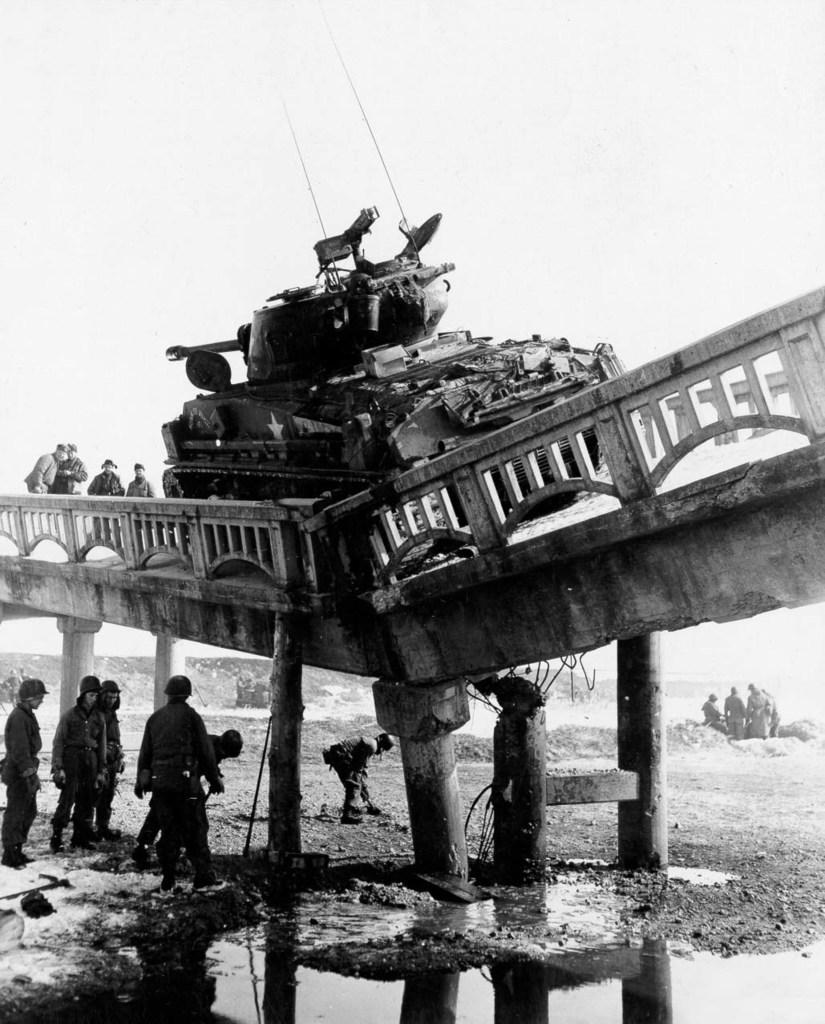Please provide a concise description of this image. In this image I can see group of people standing and I can also see few pillars. Background I can see the bridge and I can see some object on the bridge and the image is in black and white. 